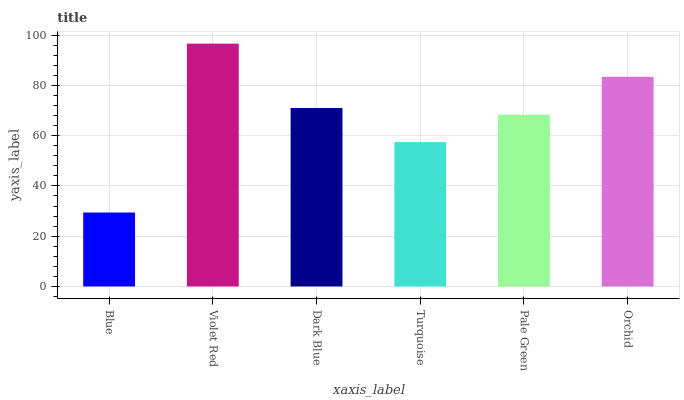Is Dark Blue the minimum?
Answer yes or no. No. Is Dark Blue the maximum?
Answer yes or no. No. Is Violet Red greater than Dark Blue?
Answer yes or no. Yes. Is Dark Blue less than Violet Red?
Answer yes or no. Yes. Is Dark Blue greater than Violet Red?
Answer yes or no. No. Is Violet Red less than Dark Blue?
Answer yes or no. No. Is Dark Blue the high median?
Answer yes or no. Yes. Is Pale Green the low median?
Answer yes or no. Yes. Is Orchid the high median?
Answer yes or no. No. Is Violet Red the low median?
Answer yes or no. No. 